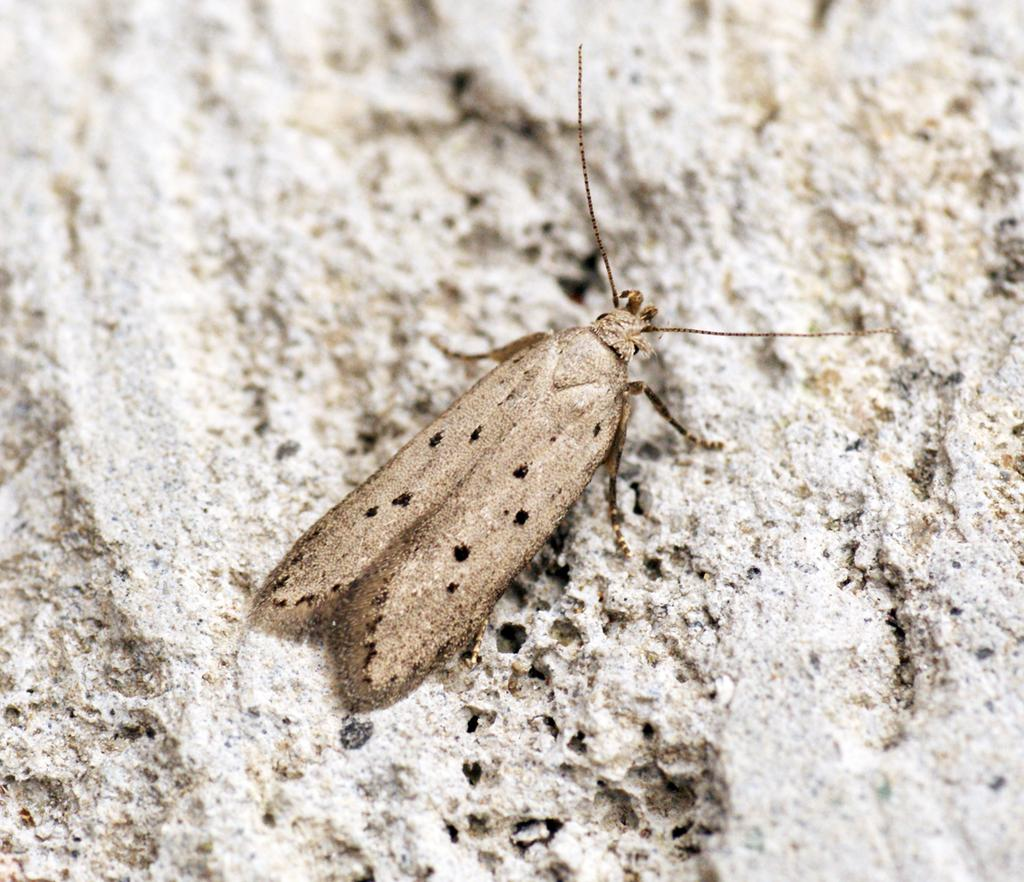What type of creature is present in the image? There is an insect in the image. Can you describe the color of the insect? The insect is brown in color. How many apples are present in the image? There are no apples present in the image; it features an insect. What is the plot of the story depicted in the image? There is no story or plot depicted in the image, as it only features an insect. 